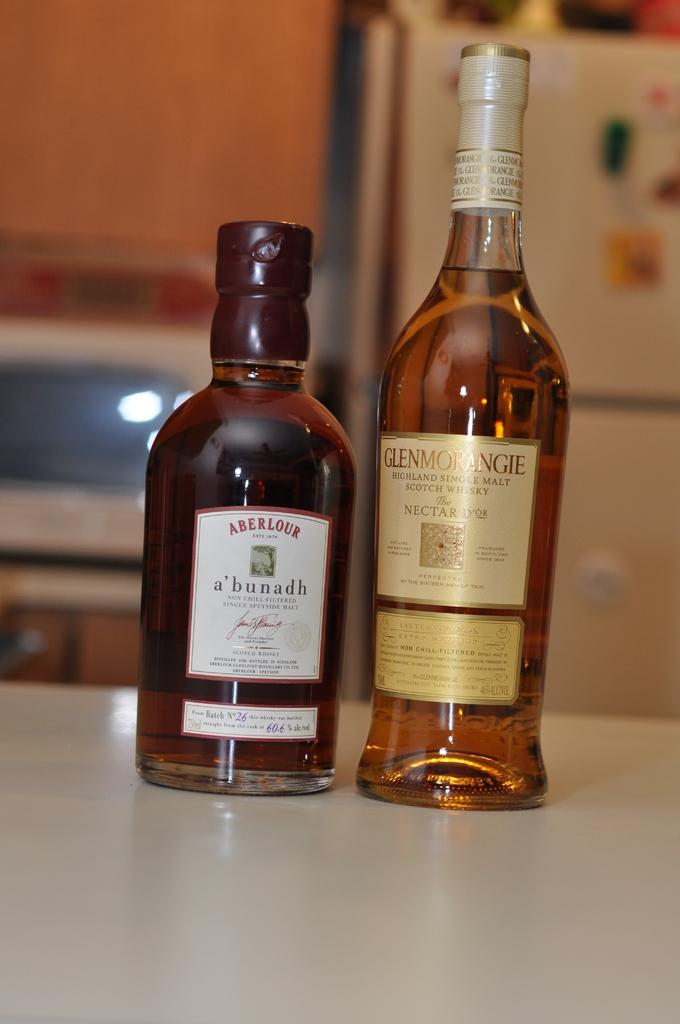<image>
Give a short and clear explanation of the subsequent image. Two bottles of liquor that say Aberlour and Glenmorangie. 